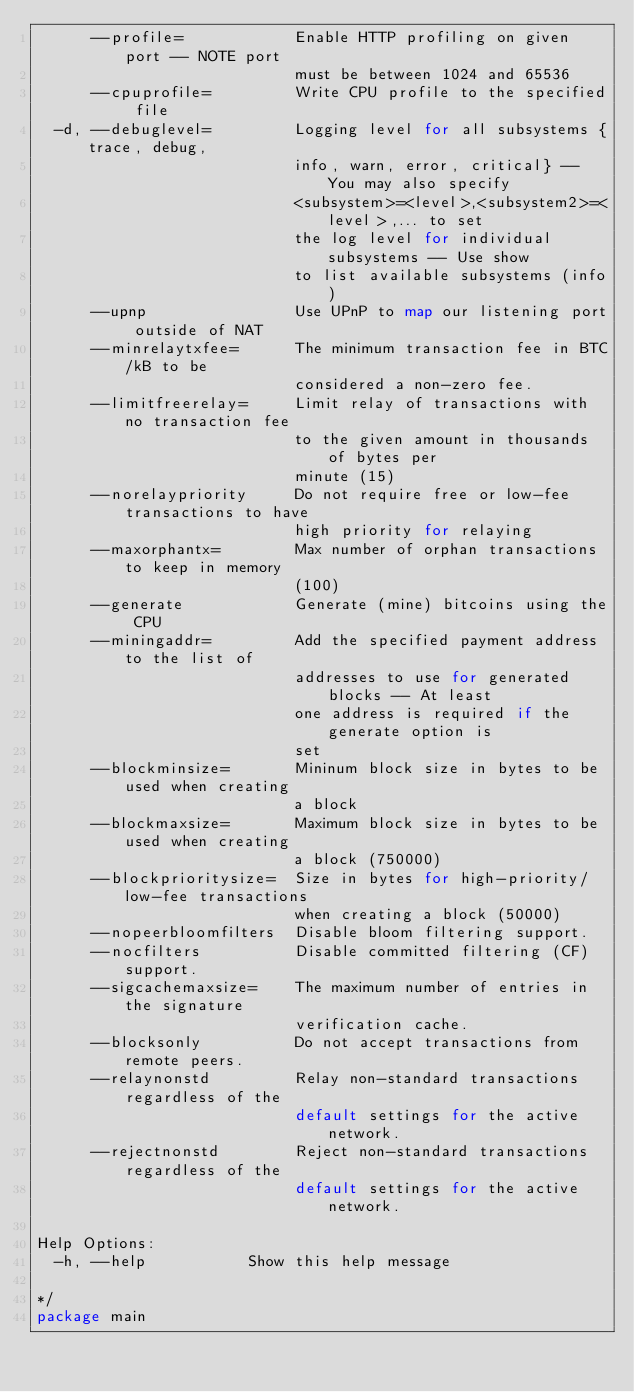Convert code to text. <code><loc_0><loc_0><loc_500><loc_500><_Go_>      --profile=            Enable HTTP profiling on given port -- NOTE port
                            must be between 1024 and 65536
      --cpuprofile=         Write CPU profile to the specified file
  -d, --debuglevel=         Logging level for all subsystems {trace, debug,
                            info, warn, error, critical} -- You may also specify
                            <subsystem>=<level>,<subsystem2>=<level>,... to set
                            the log level for individual subsystems -- Use show
                            to list available subsystems (info)
      --upnp                Use UPnP to map our listening port outside of NAT
      --minrelaytxfee=      The minimum transaction fee in BTC/kB to be
                            considered a non-zero fee.
      --limitfreerelay=     Limit relay of transactions with no transaction fee
                            to the given amount in thousands of bytes per
                            minute (15)
      --norelaypriority     Do not require free or low-fee transactions to have
                            high priority for relaying
      --maxorphantx=        Max number of orphan transactions to keep in memory
                            (100)
      --generate            Generate (mine) bitcoins using the CPU
      --miningaddr=         Add the specified payment address to the list of
                            addresses to use for generated blocks -- At least
                            one address is required if the generate option is
                            set
      --blockminsize=       Mininum block size in bytes to be used when creating
                            a block
      --blockmaxsize=       Maximum block size in bytes to be used when creating
                            a block (750000)
      --blockprioritysize=  Size in bytes for high-priority/low-fee transactions
                            when creating a block (50000)
      --nopeerbloomfilters  Disable bloom filtering support.
      --nocfilters          Disable committed filtering (CF) support.
      --sigcachemaxsize=    The maximum number of entries in the signature
                            verification cache.
      --blocksonly          Do not accept transactions from remote peers.
      --relaynonstd         Relay non-standard transactions regardless of the
                            default settings for the active network.
      --rejectnonstd        Reject non-standard transactions regardless of the
                            default settings for the active network.

Help Options:
  -h, --help           Show this help message

*/
package main
</code> 